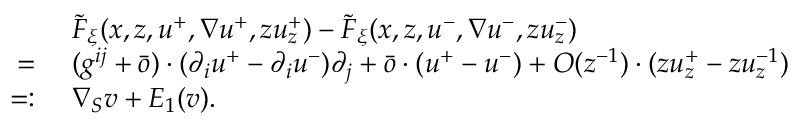Convert formula to latex. <formula><loc_0><loc_0><loc_500><loc_500>\begin{array} { r l } & { \ \tilde { F } _ { \xi } ( x , z , u ^ { + } , \nabla u ^ { + } , z u _ { z } ^ { + } ) - \tilde { F } _ { \xi } ( x , z , u ^ { - } , \nabla u ^ { - } , z u _ { z } ^ { - } ) } \\ { = } & { \ ( g ^ { i j } + \bar { o } ) \cdot ( \partial _ { i } u ^ { + } - \partial _ { i } u ^ { - } ) \partial _ { j } + \bar { o } \cdot ( u ^ { + } - u ^ { - } ) + O ( z ^ { - 1 } ) \cdot ( z u _ { z } ^ { + } - z u _ { z } ^ { - 1 } ) } \\ { = \colon } & { \ \nabla _ { S } v + E _ { 1 } ( v ) . } \end{array}</formula> 